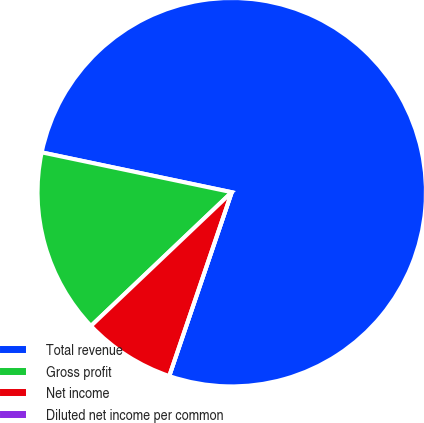Convert chart. <chart><loc_0><loc_0><loc_500><loc_500><pie_chart><fcel>Total revenue<fcel>Gross profit<fcel>Net income<fcel>Diluted net income per common<nl><fcel>76.92%<fcel>15.38%<fcel>7.69%<fcel>0.0%<nl></chart> 